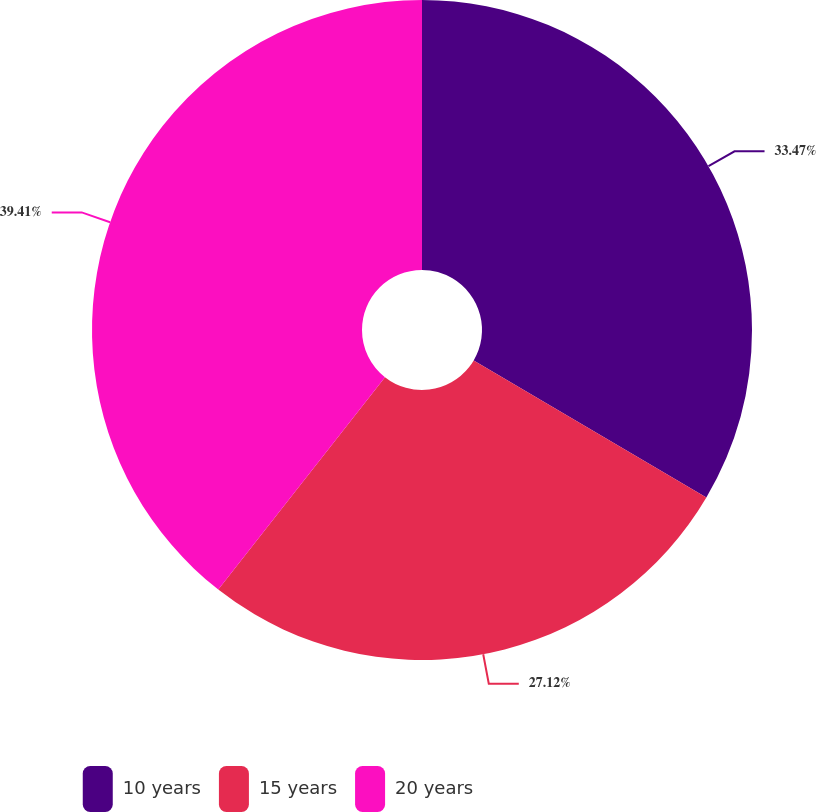Convert chart to OTSL. <chart><loc_0><loc_0><loc_500><loc_500><pie_chart><fcel>10 years<fcel>15 years<fcel>20 years<nl><fcel>33.47%<fcel>27.12%<fcel>39.41%<nl></chart> 